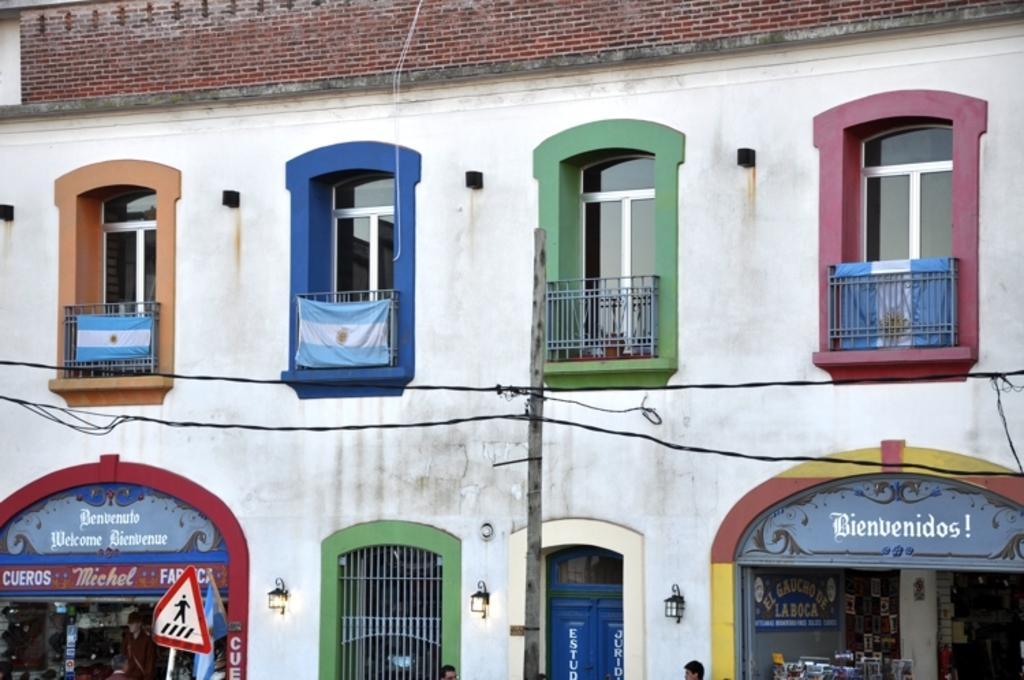Could you give a brief overview of what you see in this image? In the picture I can see a building with glass windows and balcony. Here we can see flags, we can see stores in which we can see few objects are kept, we can see name boards, lights, current polls, wires, caution board and the brick wall. 